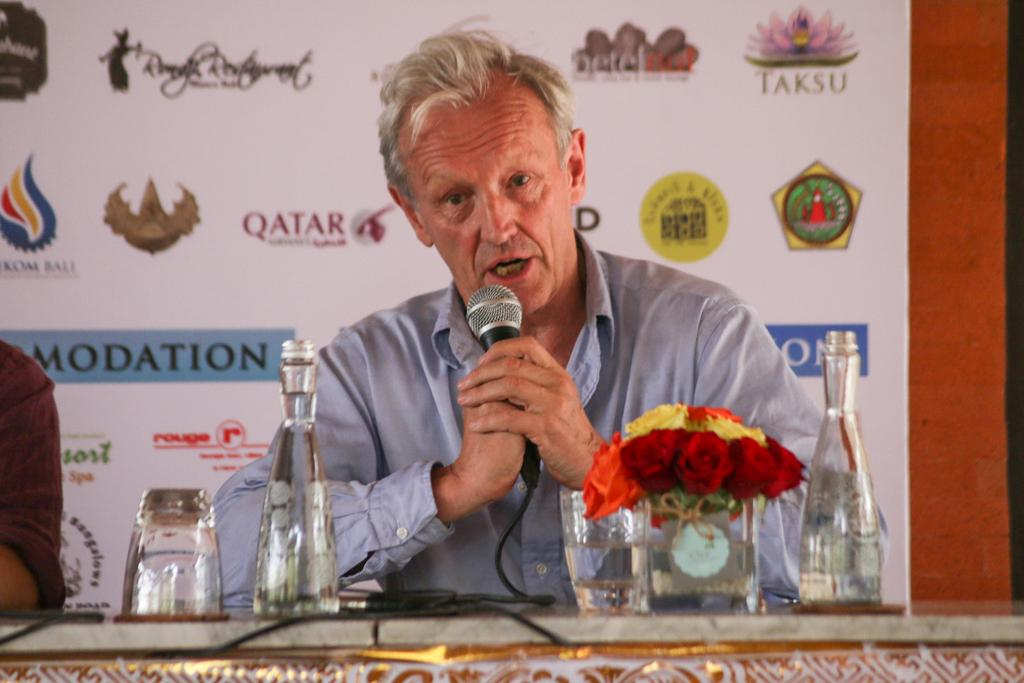Provide a one-sentence caption for the provided image. A coach gives a press conference that is sponsored by compiles like Taksu. 